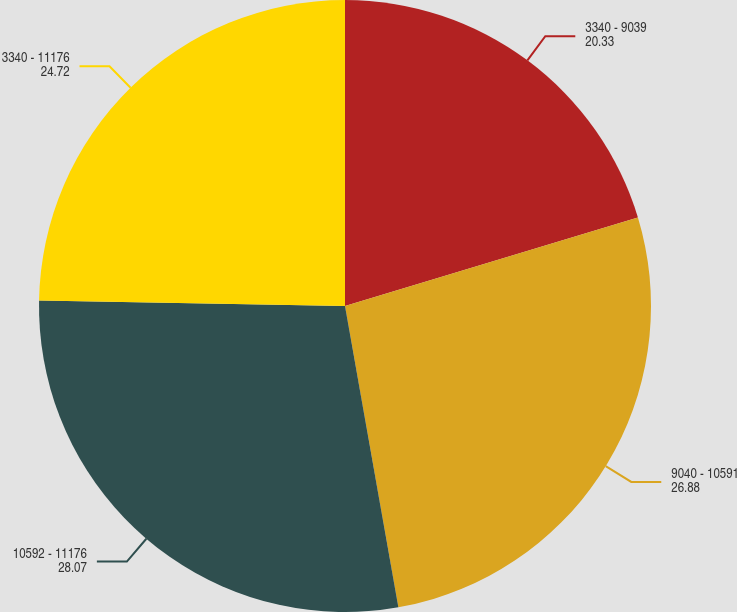Convert chart to OTSL. <chart><loc_0><loc_0><loc_500><loc_500><pie_chart><fcel>3340 - 9039<fcel>9040 - 10591<fcel>10592 - 11176<fcel>3340 - 11176<nl><fcel>20.33%<fcel>26.88%<fcel>28.07%<fcel>24.72%<nl></chart> 